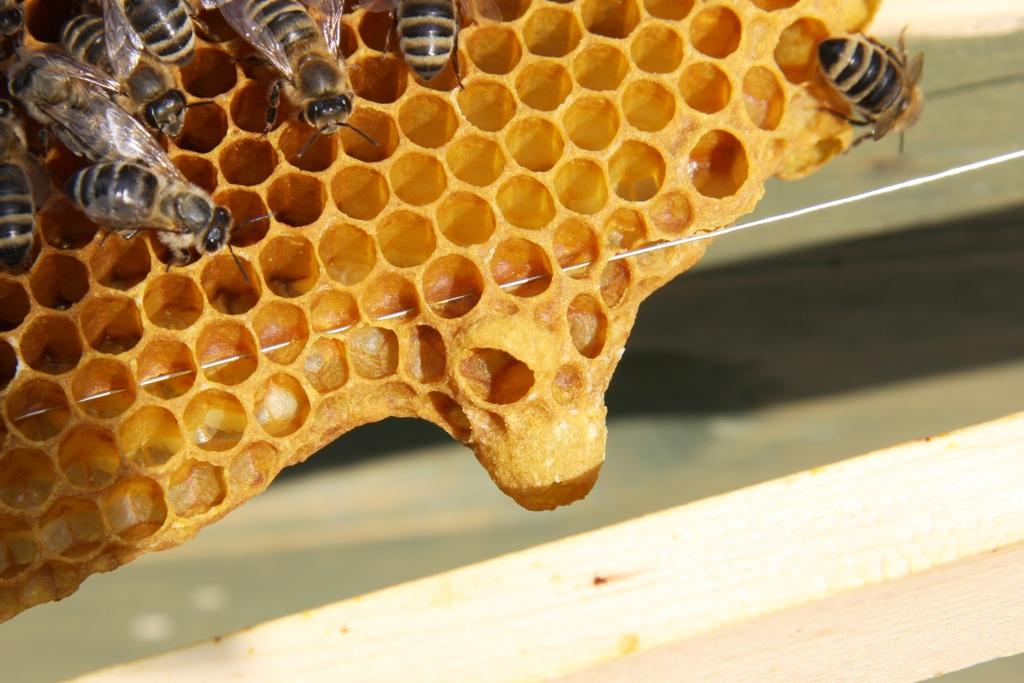What is the main subject of the image? The main subject of the image is a honeycomb. Are there any other living organisms present in the image? Yes, there are honey bees in the image. What type of silver material can be seen on the slope in the image? There is no silver material or slope present in the image; it features a honeycomb and honey bees. 